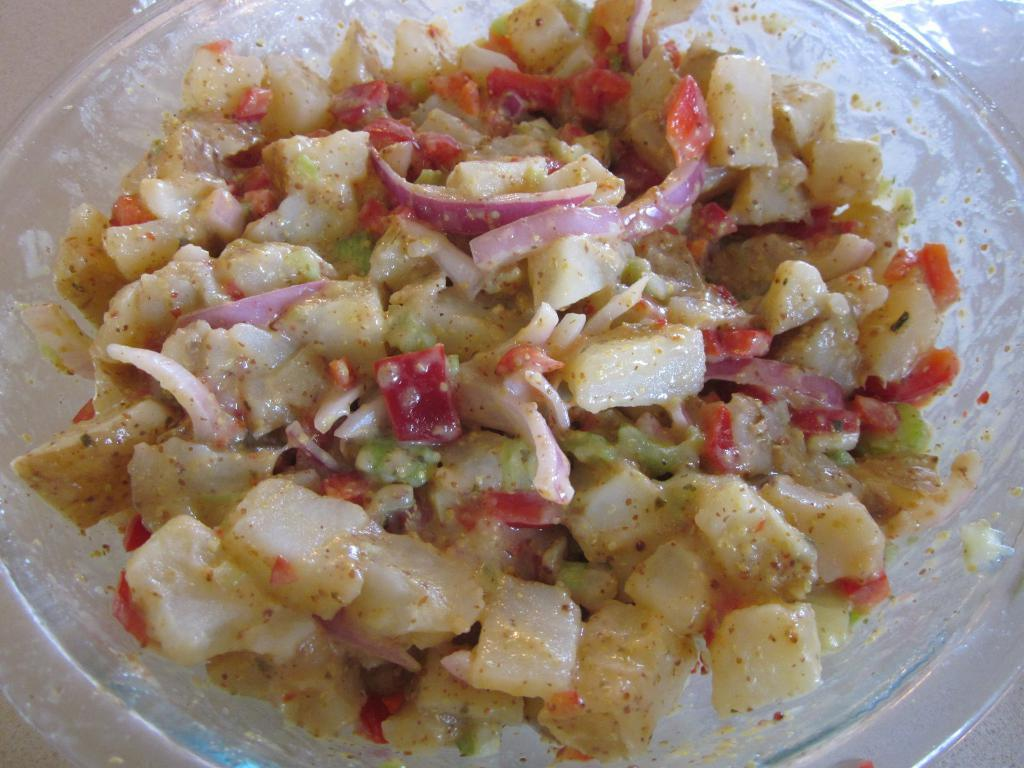What type of furniture is present in the image? There is a table in the image. What is placed on the table? There is a bowl on the table. What is inside the bowl on the table? There is a salad in the bowl. What color is the hair on the flame in the image? There is no hair or flame present in the image; it features a table, a bowl, and a salad. How many balls can be seen in the image? There are no balls present in the image. 